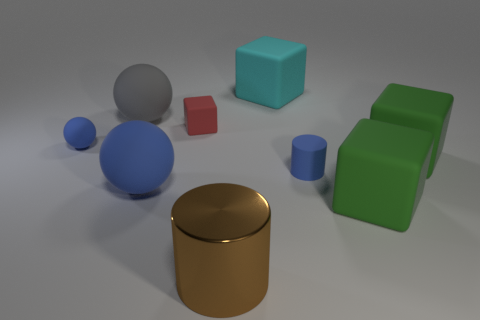How many cubes are either large yellow objects or gray matte objects?
Make the answer very short. 0. What number of large things are there?
Your answer should be very brief. 6. Does the large cyan matte thing have the same shape as the tiny blue rubber thing on the left side of the large gray matte sphere?
Ensure brevity in your answer.  No. What size is the other matte ball that is the same color as the tiny rubber ball?
Your answer should be compact. Large. What number of things are purple shiny blocks or matte objects?
Ensure brevity in your answer.  8. There is a cyan matte thing that is on the right side of the small blue object to the left of the big brown metal cylinder; what is its shape?
Keep it short and to the point. Cube. There is a small blue rubber object on the left side of the small blue rubber cylinder; is it the same shape as the big metal thing?
Keep it short and to the point. No. The blue cylinder that is made of the same material as the cyan object is what size?
Offer a very short reply. Small. How many objects are either blue spheres that are on the right side of the small blue ball or large matte spheres that are in front of the gray matte sphere?
Make the answer very short. 1. Are there the same number of large brown metal objects that are on the right side of the big cyan thing and big matte balls that are in front of the small sphere?
Keep it short and to the point. No. 